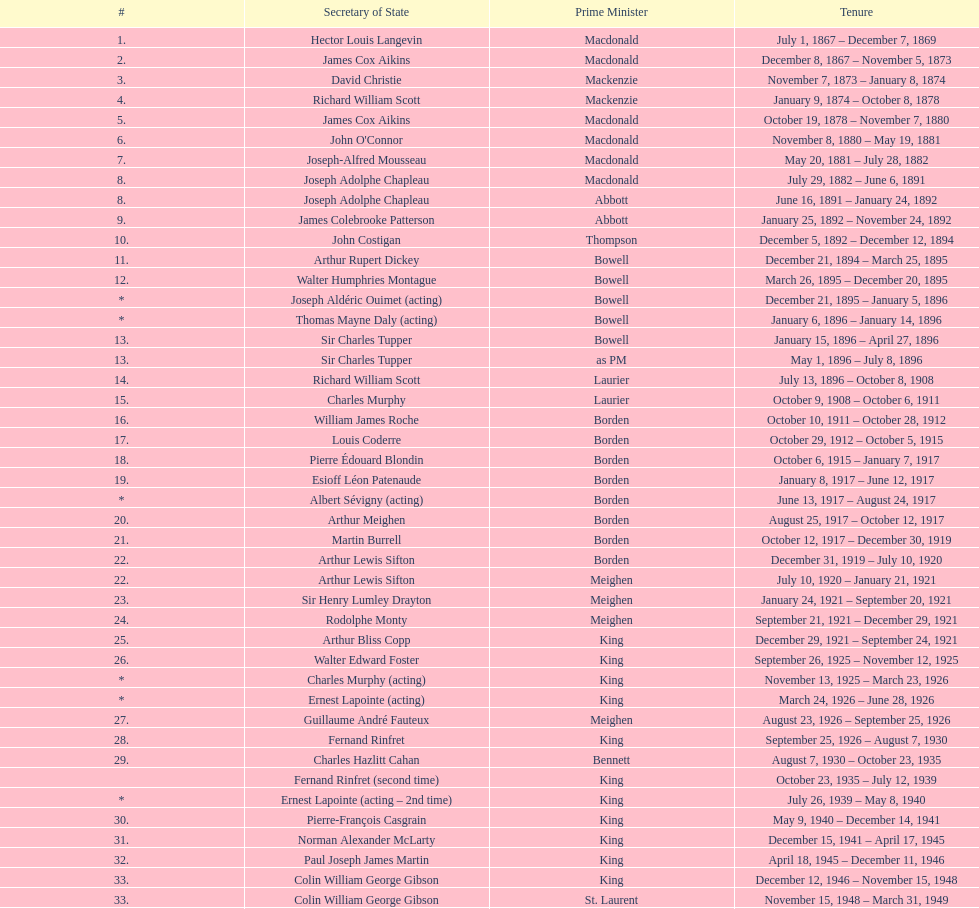Can you name the secretary of state who held their position during the tenures of both prime minister laurier and prime minister king? Charles Murphy. 